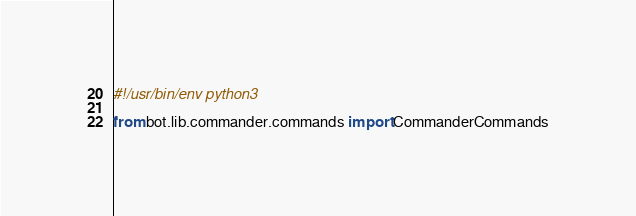<code> <loc_0><loc_0><loc_500><loc_500><_Python_>#!/usr/bin/env python3

from bot.lib.commander.commands import CommanderCommands</code> 